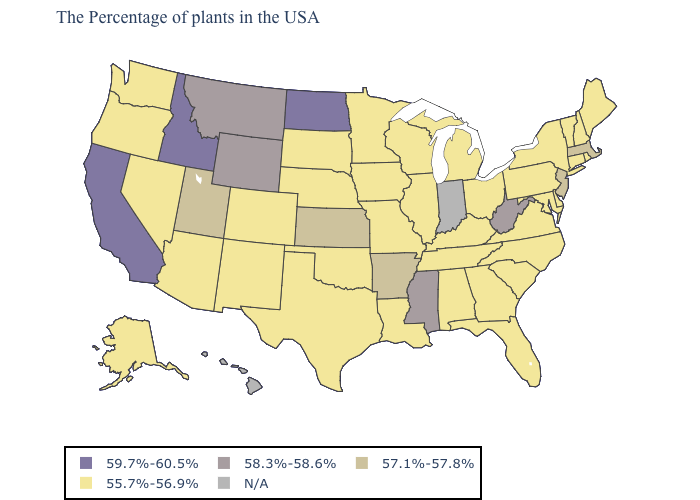What is the lowest value in the MidWest?
Concise answer only. 55.7%-56.9%. What is the value of Louisiana?
Short answer required. 55.7%-56.9%. What is the value of New Jersey?
Give a very brief answer. 57.1%-57.8%. Name the states that have a value in the range N/A?
Quick response, please. Indiana, Hawaii. Does Washington have the highest value in the USA?
Answer briefly. No. Does the map have missing data?
Give a very brief answer. Yes. Name the states that have a value in the range 57.1%-57.8%?
Write a very short answer. Massachusetts, New Jersey, Arkansas, Kansas, Utah. Which states have the lowest value in the USA?
Be succinct. Maine, Rhode Island, New Hampshire, Vermont, Connecticut, New York, Delaware, Maryland, Pennsylvania, Virginia, North Carolina, South Carolina, Ohio, Florida, Georgia, Michigan, Kentucky, Alabama, Tennessee, Wisconsin, Illinois, Louisiana, Missouri, Minnesota, Iowa, Nebraska, Oklahoma, Texas, South Dakota, Colorado, New Mexico, Arizona, Nevada, Washington, Oregon, Alaska. What is the value of Tennessee?
Be succinct. 55.7%-56.9%. What is the lowest value in states that border North Carolina?
Quick response, please. 55.7%-56.9%. Name the states that have a value in the range 55.7%-56.9%?
Answer briefly. Maine, Rhode Island, New Hampshire, Vermont, Connecticut, New York, Delaware, Maryland, Pennsylvania, Virginia, North Carolina, South Carolina, Ohio, Florida, Georgia, Michigan, Kentucky, Alabama, Tennessee, Wisconsin, Illinois, Louisiana, Missouri, Minnesota, Iowa, Nebraska, Oklahoma, Texas, South Dakota, Colorado, New Mexico, Arizona, Nevada, Washington, Oregon, Alaska. What is the lowest value in the USA?
Write a very short answer. 55.7%-56.9%. Is the legend a continuous bar?
Concise answer only. No. Does New Hampshire have the lowest value in the USA?
Be succinct. Yes. 